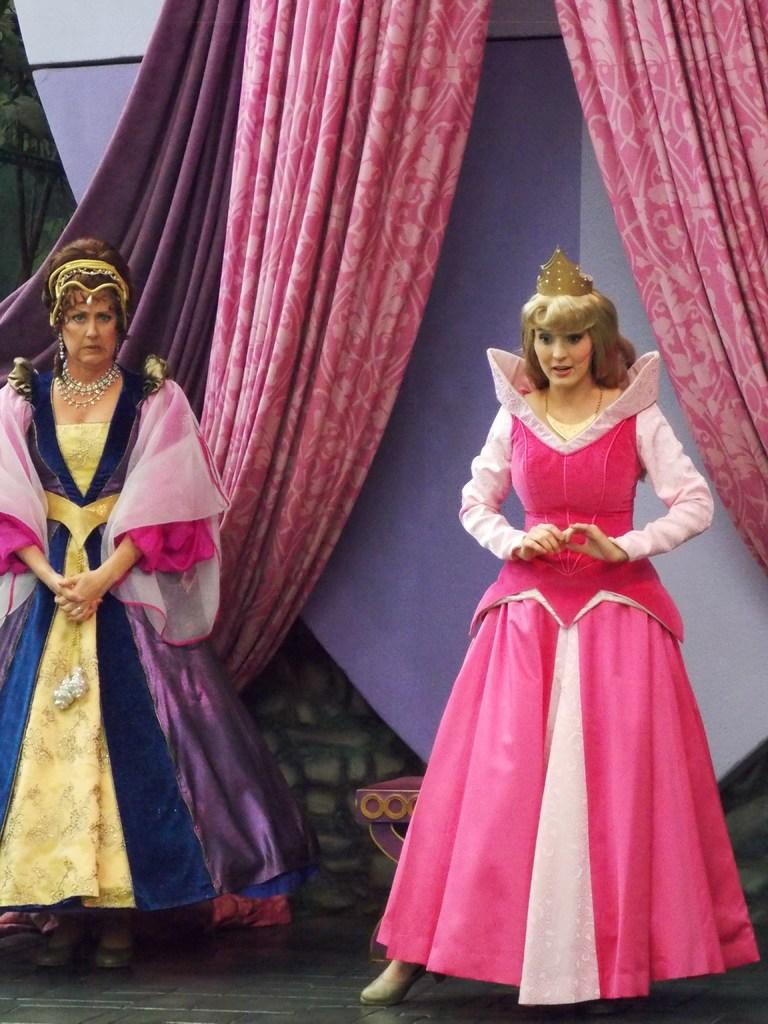How many women are in the image? There are two women in the image. What are the women wearing? The women are wearing different costumes. What can be seen attached to a wall in the image? There are curtains visible in the image, and they are attached to a wall. Is there a parcel being delivered to the women in the image? There is no parcel visible in the image. What is the current time according to the clock in the image? There is no clock present in the image. 